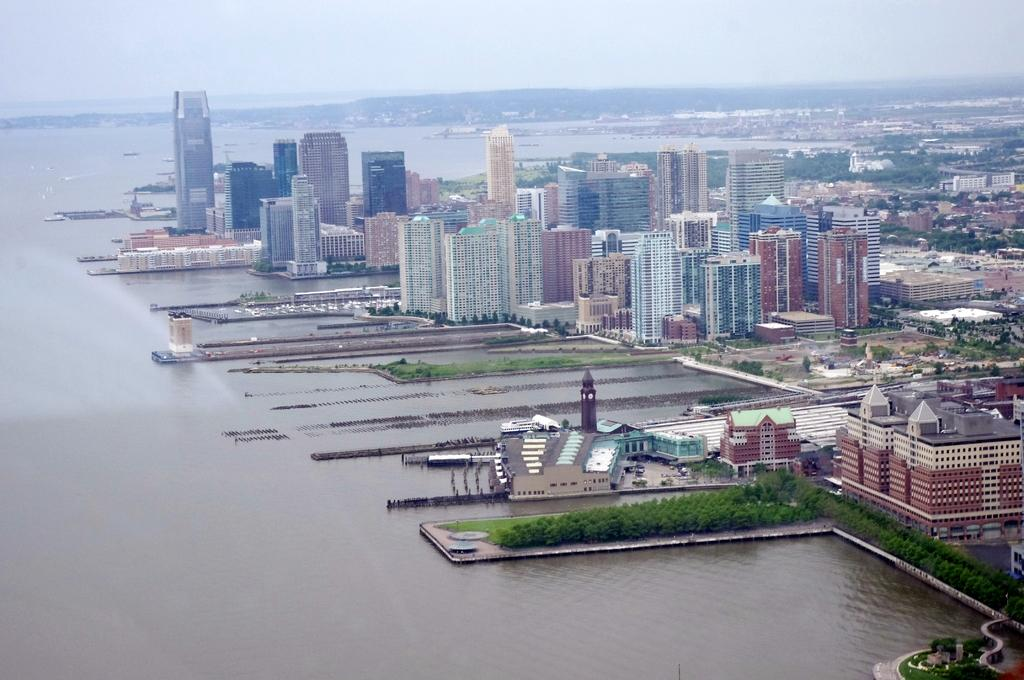What can be seen in the background of the image? The sky is visible in the background of the image. What type of structures are present in the image? There are buildings in the image. What type of vegetation is present in the image? There are trees in the image. What natural element is visible in the image? There is water visible in the image. What type of ground cover is present in the image? There is grass in the image. What type of learning is taking place in the hospital depicted in the image? There is no hospital or learning depicted in the image; it features the sky, buildings, trees, water, and grass. 